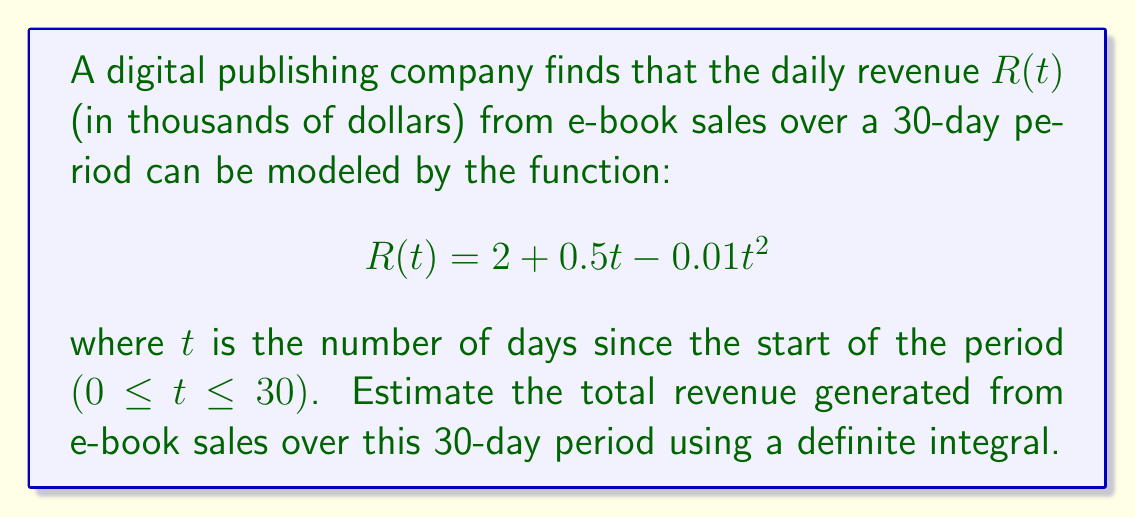Can you solve this math problem? To estimate the total revenue generated from e-book sales over the 30-day period, we need to calculate the area under the curve of the revenue function $R(t)$ from $t=0$ to $t=30$. This can be done using a definite integral.

Steps:
1) Set up the definite integral:
   $$\int_0^{30} R(t) dt = \int_0^{30} (2 + 0.5t - 0.01t^2) dt$$

2) Integrate the function:
   $$\int_0^{30} (2 + 0.5t - 0.01t^2) dt = [2t + 0.25t^2 - \frac{0.01}{3}t^3]_0^{30}$$

3) Evaluate the integral:
   $$= (2(30) + 0.25(30)^2 - \frac{0.01}{3}(30)^3) - (2(0) + 0.25(0)^2 - \frac{0.01}{3}(0)^3)$$
   $$= (60 + 225 - 90) - 0$$
   $$= 195$$

4) Interpret the result:
   Since $R(t)$ was in thousands of dollars, the result 195 represents 195,000 dollars.
Answer: The total revenue generated from e-book sales over the 30-day period is estimated to be $195,000. 